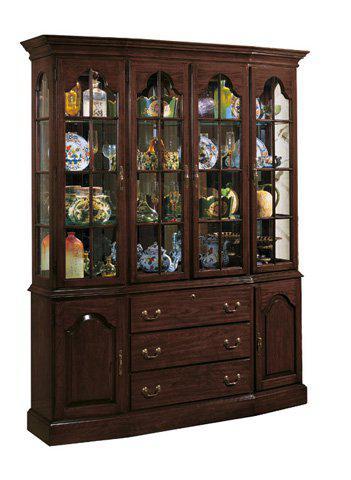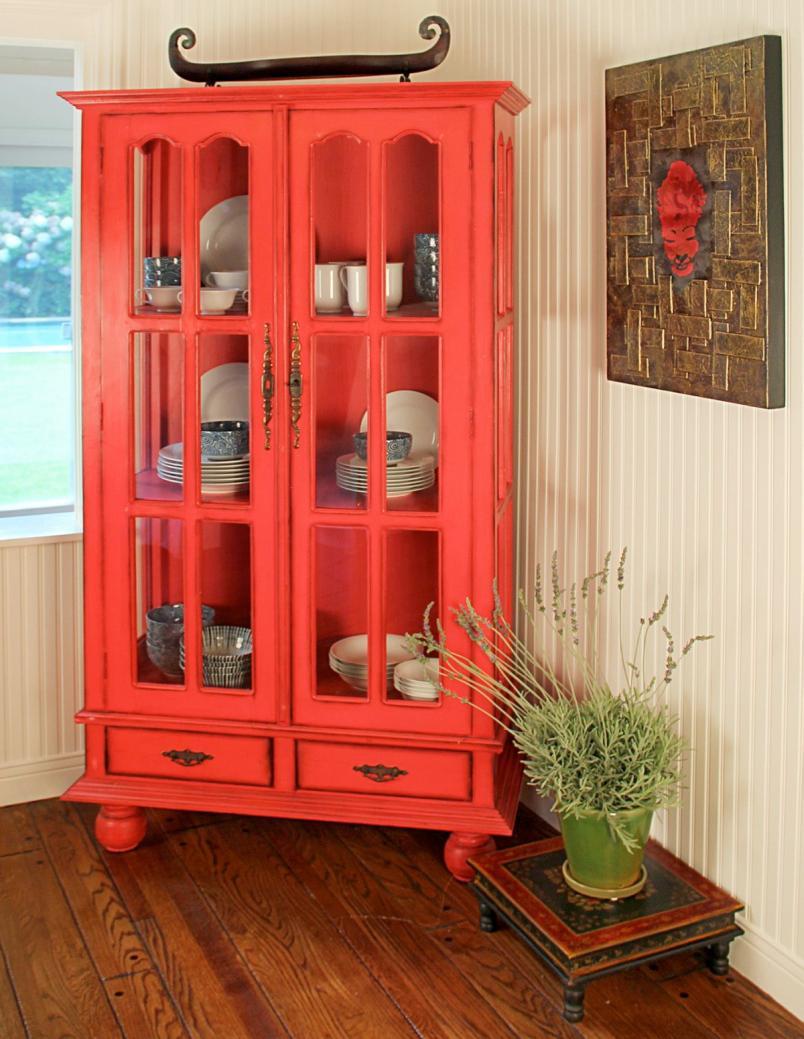The first image is the image on the left, the second image is the image on the right. Given the left and right images, does the statement "There are exactly three drawers on the cabinet in the image on the right." hold true? Answer yes or no. No. 